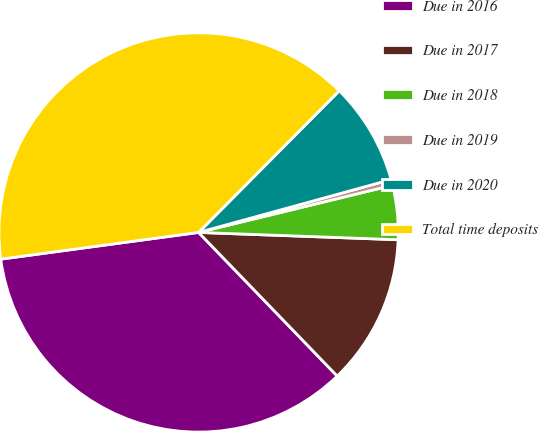Convert chart to OTSL. <chart><loc_0><loc_0><loc_500><loc_500><pie_chart><fcel>Due in 2016<fcel>Due in 2017<fcel>Due in 2018<fcel>Due in 2019<fcel>Due in 2020<fcel>Total time deposits<nl><fcel>35.08%<fcel>12.2%<fcel>4.38%<fcel>0.47%<fcel>8.29%<fcel>39.58%<nl></chart> 